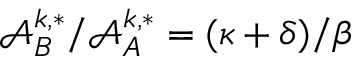<formula> <loc_0><loc_0><loc_500><loc_500>{ \mathcal { A } _ { B } ^ { k , * } } / { \mathcal { A } _ { A } ^ { k , * } } = ( { \kappa + \delta } ) / { \beta }</formula> 